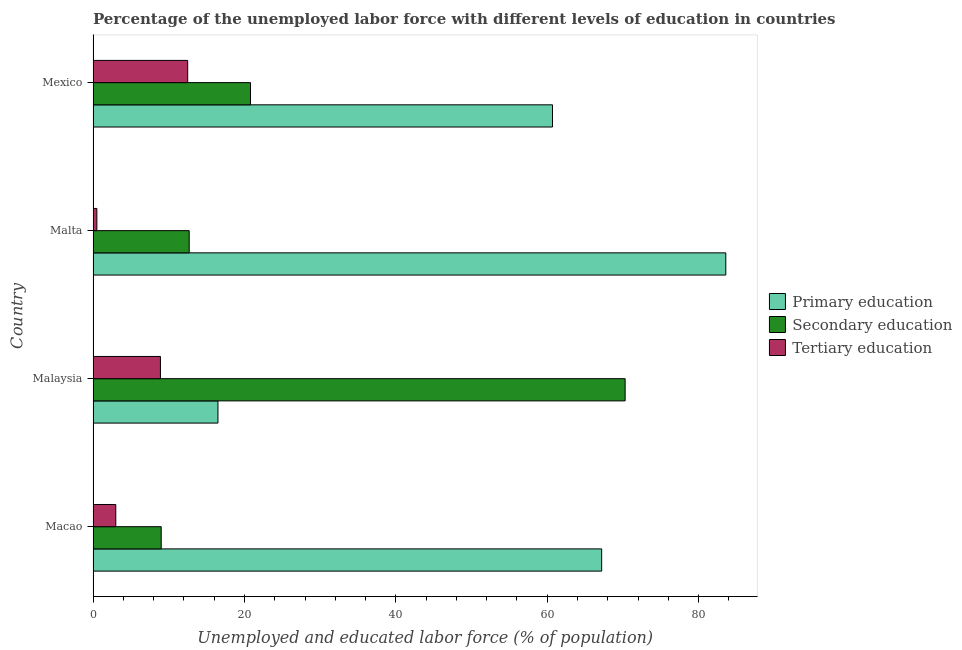How many different coloured bars are there?
Make the answer very short. 3. Are the number of bars on each tick of the Y-axis equal?
Ensure brevity in your answer.  Yes. How many bars are there on the 3rd tick from the bottom?
Provide a succinct answer. 3. What is the label of the 1st group of bars from the top?
Your answer should be compact. Mexico. In how many cases, is the number of bars for a given country not equal to the number of legend labels?
Provide a short and direct response. 0. What is the percentage of labor force who received primary education in Macao?
Your answer should be very brief. 67.2. Across all countries, what is the maximum percentage of labor force who received primary education?
Provide a succinct answer. 83.6. Across all countries, what is the minimum percentage of labor force who received secondary education?
Ensure brevity in your answer.  9. In which country was the percentage of labor force who received secondary education maximum?
Make the answer very short. Malaysia. In which country was the percentage of labor force who received primary education minimum?
Provide a succinct answer. Malaysia. What is the total percentage of labor force who received tertiary education in the graph?
Give a very brief answer. 24.9. What is the difference between the percentage of labor force who received secondary education in Macao and that in Malaysia?
Your response must be concise. -61.3. What is the difference between the percentage of labor force who received secondary education in Mexico and the percentage of labor force who received tertiary education in Macao?
Keep it short and to the point. 17.8. What is the average percentage of labor force who received primary education per country?
Provide a short and direct response. 57. What is the difference between the percentage of labor force who received primary education and percentage of labor force who received secondary education in Malaysia?
Give a very brief answer. -53.8. In how many countries, is the percentage of labor force who received tertiary education greater than 8 %?
Provide a succinct answer. 2. What is the ratio of the percentage of labor force who received secondary education in Macao to that in Malaysia?
Provide a succinct answer. 0.13. Is the percentage of labor force who received primary education in Malta less than that in Mexico?
Offer a terse response. No. Is the difference between the percentage of labor force who received tertiary education in Malta and Mexico greater than the difference between the percentage of labor force who received secondary education in Malta and Mexico?
Your response must be concise. No. What is the difference between the highest and the lowest percentage of labor force who received tertiary education?
Offer a terse response. 12. In how many countries, is the percentage of labor force who received primary education greater than the average percentage of labor force who received primary education taken over all countries?
Your response must be concise. 3. Is the sum of the percentage of labor force who received tertiary education in Malta and Mexico greater than the maximum percentage of labor force who received secondary education across all countries?
Make the answer very short. No. What does the 1st bar from the top in Mexico represents?
Ensure brevity in your answer.  Tertiary education. What does the 1st bar from the bottom in Macao represents?
Make the answer very short. Primary education. Is it the case that in every country, the sum of the percentage of labor force who received primary education and percentage of labor force who received secondary education is greater than the percentage of labor force who received tertiary education?
Keep it short and to the point. Yes. How many bars are there?
Keep it short and to the point. 12. Are all the bars in the graph horizontal?
Make the answer very short. Yes. How many countries are there in the graph?
Your response must be concise. 4. What is the difference between two consecutive major ticks on the X-axis?
Offer a very short reply. 20. Are the values on the major ticks of X-axis written in scientific E-notation?
Offer a terse response. No. Does the graph contain grids?
Give a very brief answer. No. How many legend labels are there?
Give a very brief answer. 3. How are the legend labels stacked?
Ensure brevity in your answer.  Vertical. What is the title of the graph?
Your response must be concise. Percentage of the unemployed labor force with different levels of education in countries. Does "Labor Market" appear as one of the legend labels in the graph?
Keep it short and to the point. No. What is the label or title of the X-axis?
Ensure brevity in your answer.  Unemployed and educated labor force (% of population). What is the Unemployed and educated labor force (% of population) of Primary education in Macao?
Your answer should be very brief. 67.2. What is the Unemployed and educated labor force (% of population) in Secondary education in Malaysia?
Offer a terse response. 70.3. What is the Unemployed and educated labor force (% of population) of Tertiary education in Malaysia?
Offer a terse response. 8.9. What is the Unemployed and educated labor force (% of population) of Primary education in Malta?
Offer a very short reply. 83.6. What is the Unemployed and educated labor force (% of population) of Secondary education in Malta?
Provide a short and direct response. 12.7. What is the Unemployed and educated labor force (% of population) of Primary education in Mexico?
Ensure brevity in your answer.  60.7. What is the Unemployed and educated labor force (% of population) of Secondary education in Mexico?
Your answer should be compact. 20.8. What is the Unemployed and educated labor force (% of population) of Tertiary education in Mexico?
Make the answer very short. 12.5. Across all countries, what is the maximum Unemployed and educated labor force (% of population) of Primary education?
Make the answer very short. 83.6. Across all countries, what is the maximum Unemployed and educated labor force (% of population) in Secondary education?
Offer a very short reply. 70.3. Across all countries, what is the minimum Unemployed and educated labor force (% of population) in Primary education?
Provide a succinct answer. 16.5. What is the total Unemployed and educated labor force (% of population) of Primary education in the graph?
Your response must be concise. 228. What is the total Unemployed and educated labor force (% of population) of Secondary education in the graph?
Provide a short and direct response. 112.8. What is the total Unemployed and educated labor force (% of population) in Tertiary education in the graph?
Offer a very short reply. 24.9. What is the difference between the Unemployed and educated labor force (% of population) of Primary education in Macao and that in Malaysia?
Provide a succinct answer. 50.7. What is the difference between the Unemployed and educated labor force (% of population) of Secondary education in Macao and that in Malaysia?
Keep it short and to the point. -61.3. What is the difference between the Unemployed and educated labor force (% of population) in Primary education in Macao and that in Malta?
Provide a short and direct response. -16.4. What is the difference between the Unemployed and educated labor force (% of population) in Secondary education in Macao and that in Malta?
Provide a short and direct response. -3.7. What is the difference between the Unemployed and educated labor force (% of population) in Secondary education in Macao and that in Mexico?
Provide a short and direct response. -11.8. What is the difference between the Unemployed and educated labor force (% of population) in Tertiary education in Macao and that in Mexico?
Provide a succinct answer. -9.5. What is the difference between the Unemployed and educated labor force (% of population) in Primary education in Malaysia and that in Malta?
Offer a terse response. -67.1. What is the difference between the Unemployed and educated labor force (% of population) in Secondary education in Malaysia and that in Malta?
Your answer should be compact. 57.6. What is the difference between the Unemployed and educated labor force (% of population) in Primary education in Malaysia and that in Mexico?
Make the answer very short. -44.2. What is the difference between the Unemployed and educated labor force (% of population) of Secondary education in Malaysia and that in Mexico?
Your answer should be very brief. 49.5. What is the difference between the Unemployed and educated labor force (% of population) in Tertiary education in Malaysia and that in Mexico?
Ensure brevity in your answer.  -3.6. What is the difference between the Unemployed and educated labor force (% of population) in Primary education in Malta and that in Mexico?
Make the answer very short. 22.9. What is the difference between the Unemployed and educated labor force (% of population) in Secondary education in Malta and that in Mexico?
Your answer should be very brief. -8.1. What is the difference between the Unemployed and educated labor force (% of population) of Tertiary education in Malta and that in Mexico?
Your answer should be very brief. -12. What is the difference between the Unemployed and educated labor force (% of population) in Primary education in Macao and the Unemployed and educated labor force (% of population) in Secondary education in Malaysia?
Make the answer very short. -3.1. What is the difference between the Unemployed and educated labor force (% of population) of Primary education in Macao and the Unemployed and educated labor force (% of population) of Tertiary education in Malaysia?
Your response must be concise. 58.3. What is the difference between the Unemployed and educated labor force (% of population) in Secondary education in Macao and the Unemployed and educated labor force (% of population) in Tertiary education in Malaysia?
Ensure brevity in your answer.  0.1. What is the difference between the Unemployed and educated labor force (% of population) in Primary education in Macao and the Unemployed and educated labor force (% of population) in Secondary education in Malta?
Provide a succinct answer. 54.5. What is the difference between the Unemployed and educated labor force (% of population) in Primary education in Macao and the Unemployed and educated labor force (% of population) in Tertiary education in Malta?
Your answer should be compact. 66.7. What is the difference between the Unemployed and educated labor force (% of population) in Secondary education in Macao and the Unemployed and educated labor force (% of population) in Tertiary education in Malta?
Your response must be concise. 8.5. What is the difference between the Unemployed and educated labor force (% of population) of Primary education in Macao and the Unemployed and educated labor force (% of population) of Secondary education in Mexico?
Offer a terse response. 46.4. What is the difference between the Unemployed and educated labor force (% of population) of Primary education in Macao and the Unemployed and educated labor force (% of population) of Tertiary education in Mexico?
Your response must be concise. 54.7. What is the difference between the Unemployed and educated labor force (% of population) of Secondary education in Malaysia and the Unemployed and educated labor force (% of population) of Tertiary education in Malta?
Your response must be concise. 69.8. What is the difference between the Unemployed and educated labor force (% of population) in Primary education in Malaysia and the Unemployed and educated labor force (% of population) in Secondary education in Mexico?
Your response must be concise. -4.3. What is the difference between the Unemployed and educated labor force (% of population) in Primary education in Malaysia and the Unemployed and educated labor force (% of population) in Tertiary education in Mexico?
Give a very brief answer. 4. What is the difference between the Unemployed and educated labor force (% of population) in Secondary education in Malaysia and the Unemployed and educated labor force (% of population) in Tertiary education in Mexico?
Provide a succinct answer. 57.8. What is the difference between the Unemployed and educated labor force (% of population) in Primary education in Malta and the Unemployed and educated labor force (% of population) in Secondary education in Mexico?
Offer a very short reply. 62.8. What is the difference between the Unemployed and educated labor force (% of population) of Primary education in Malta and the Unemployed and educated labor force (% of population) of Tertiary education in Mexico?
Offer a terse response. 71.1. What is the average Unemployed and educated labor force (% of population) in Primary education per country?
Your response must be concise. 57. What is the average Unemployed and educated labor force (% of population) in Secondary education per country?
Ensure brevity in your answer.  28.2. What is the average Unemployed and educated labor force (% of population) in Tertiary education per country?
Your response must be concise. 6.22. What is the difference between the Unemployed and educated labor force (% of population) in Primary education and Unemployed and educated labor force (% of population) in Secondary education in Macao?
Your answer should be very brief. 58.2. What is the difference between the Unemployed and educated labor force (% of population) in Primary education and Unemployed and educated labor force (% of population) in Tertiary education in Macao?
Ensure brevity in your answer.  64.2. What is the difference between the Unemployed and educated labor force (% of population) of Primary education and Unemployed and educated labor force (% of population) of Secondary education in Malaysia?
Your answer should be very brief. -53.8. What is the difference between the Unemployed and educated labor force (% of population) of Secondary education and Unemployed and educated labor force (% of population) of Tertiary education in Malaysia?
Your answer should be compact. 61.4. What is the difference between the Unemployed and educated labor force (% of population) of Primary education and Unemployed and educated labor force (% of population) of Secondary education in Malta?
Your answer should be compact. 70.9. What is the difference between the Unemployed and educated labor force (% of population) in Primary education and Unemployed and educated labor force (% of population) in Tertiary education in Malta?
Offer a very short reply. 83.1. What is the difference between the Unemployed and educated labor force (% of population) in Secondary education and Unemployed and educated labor force (% of population) in Tertiary education in Malta?
Ensure brevity in your answer.  12.2. What is the difference between the Unemployed and educated labor force (% of population) of Primary education and Unemployed and educated labor force (% of population) of Secondary education in Mexico?
Offer a terse response. 39.9. What is the difference between the Unemployed and educated labor force (% of population) of Primary education and Unemployed and educated labor force (% of population) of Tertiary education in Mexico?
Provide a short and direct response. 48.2. What is the ratio of the Unemployed and educated labor force (% of population) of Primary education in Macao to that in Malaysia?
Make the answer very short. 4.07. What is the ratio of the Unemployed and educated labor force (% of population) of Secondary education in Macao to that in Malaysia?
Offer a terse response. 0.13. What is the ratio of the Unemployed and educated labor force (% of population) in Tertiary education in Macao to that in Malaysia?
Provide a short and direct response. 0.34. What is the ratio of the Unemployed and educated labor force (% of population) in Primary education in Macao to that in Malta?
Keep it short and to the point. 0.8. What is the ratio of the Unemployed and educated labor force (% of population) in Secondary education in Macao to that in Malta?
Your response must be concise. 0.71. What is the ratio of the Unemployed and educated labor force (% of population) of Tertiary education in Macao to that in Malta?
Make the answer very short. 6. What is the ratio of the Unemployed and educated labor force (% of population) in Primary education in Macao to that in Mexico?
Provide a succinct answer. 1.11. What is the ratio of the Unemployed and educated labor force (% of population) of Secondary education in Macao to that in Mexico?
Your answer should be compact. 0.43. What is the ratio of the Unemployed and educated labor force (% of population) in Tertiary education in Macao to that in Mexico?
Keep it short and to the point. 0.24. What is the ratio of the Unemployed and educated labor force (% of population) of Primary education in Malaysia to that in Malta?
Offer a terse response. 0.2. What is the ratio of the Unemployed and educated labor force (% of population) of Secondary education in Malaysia to that in Malta?
Your answer should be compact. 5.54. What is the ratio of the Unemployed and educated labor force (% of population) of Primary education in Malaysia to that in Mexico?
Provide a succinct answer. 0.27. What is the ratio of the Unemployed and educated labor force (% of population) of Secondary education in Malaysia to that in Mexico?
Provide a succinct answer. 3.38. What is the ratio of the Unemployed and educated labor force (% of population) of Tertiary education in Malaysia to that in Mexico?
Offer a very short reply. 0.71. What is the ratio of the Unemployed and educated labor force (% of population) in Primary education in Malta to that in Mexico?
Offer a very short reply. 1.38. What is the ratio of the Unemployed and educated labor force (% of population) in Secondary education in Malta to that in Mexico?
Offer a very short reply. 0.61. What is the difference between the highest and the second highest Unemployed and educated labor force (% of population) of Primary education?
Offer a very short reply. 16.4. What is the difference between the highest and the second highest Unemployed and educated labor force (% of population) of Secondary education?
Ensure brevity in your answer.  49.5. What is the difference between the highest and the lowest Unemployed and educated labor force (% of population) of Primary education?
Your response must be concise. 67.1. What is the difference between the highest and the lowest Unemployed and educated labor force (% of population) in Secondary education?
Offer a very short reply. 61.3. What is the difference between the highest and the lowest Unemployed and educated labor force (% of population) in Tertiary education?
Provide a succinct answer. 12. 